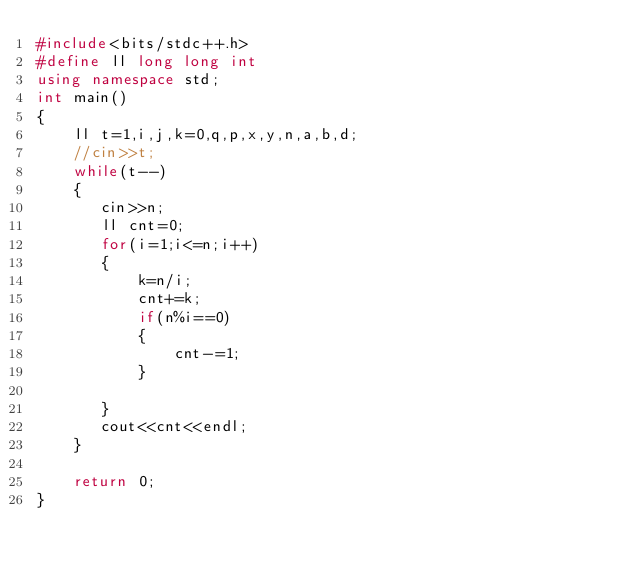<code> <loc_0><loc_0><loc_500><loc_500><_C++_>#include<bits/stdc++.h>
#define ll long long int
using namespace std;
int main()
{
    ll t=1,i,j,k=0,q,p,x,y,n,a,b,d;
    //cin>>t;
    while(t--)
    {
       cin>>n;
       ll cnt=0;
       for(i=1;i<=n;i++)
       {
           k=n/i;
           cnt+=k;
           if(n%i==0)
           {
               cnt-=1;
           }

       }
       cout<<cnt<<endl;
    }

    return 0;
}
</code> 